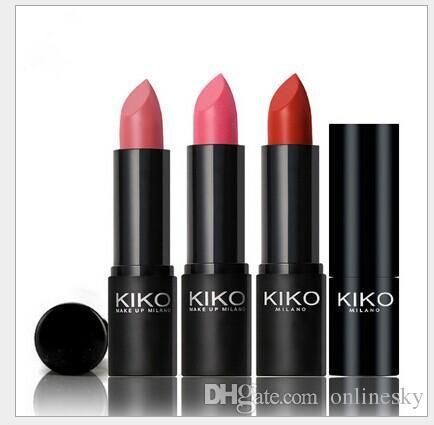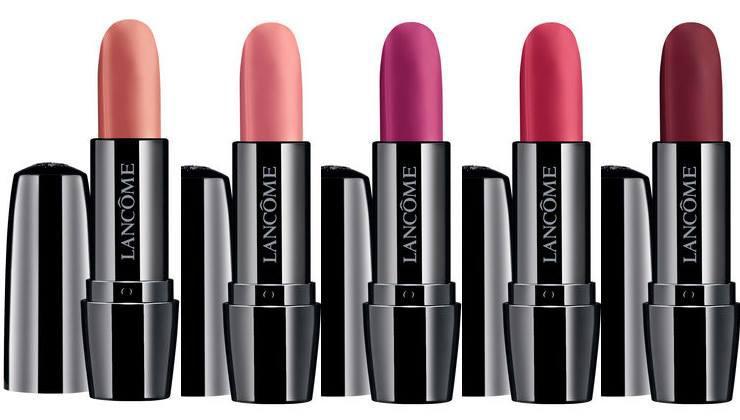The first image is the image on the left, the second image is the image on the right. For the images displayed, is the sentence "There is one closed tube of lipstick in line with all of the open tubes of lipstick." factually correct? Answer yes or no. Yes. The first image is the image on the left, the second image is the image on the right. Considering the images on both sides, is "There are exactly three lip makeups in the image on the right." valid? Answer yes or no. No. 